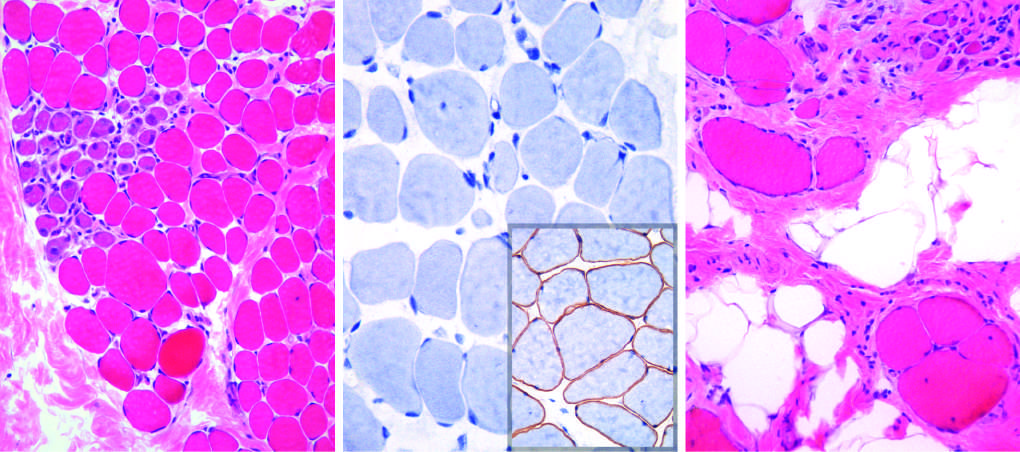s fish using a fluorescein-labeled cosmid probe for n-myc on a tissue section containing neuroblastoma maintained at a younger age?
Answer the question using a single word or phrase. No 